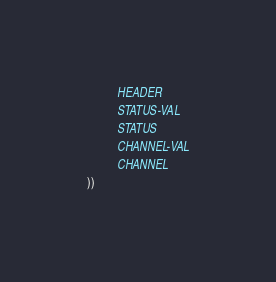<code> <loc_0><loc_0><loc_500><loc_500><_Lisp_>          HEADER
          STATUS-VAL
          STATUS
          CHANNEL-VAL
          CHANNEL
))</code> 